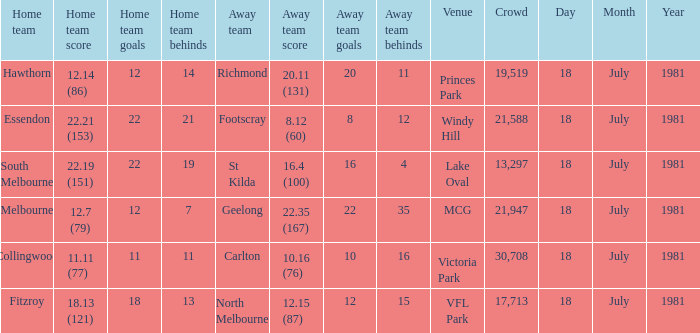What was the away team that played against Fitzroy? North Melbourne. 